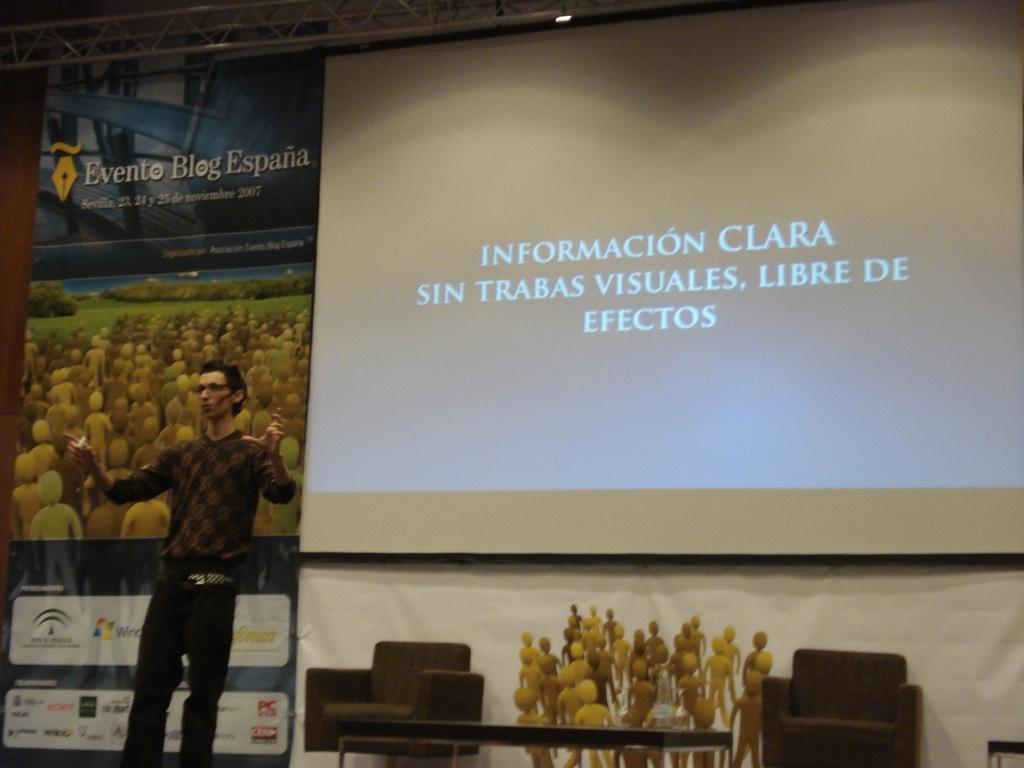What is the main subject of the image? There is a man in the image. What is the man doing in the image? The man is standing and talking. What can be seen behind the man? There is a screen and a banner behind the man. Can you describe the setting of the image? The setting might be on a stage, as indicated by the presence of a screen and cushioned chairs on either side. What type of stitch is being used to hold the badge on the man's shirt in the image? There is no badge visible on the man's shirt in the image, so it is not possible to determine the type of stitch being used. How does the heat affect the man's performance in the image? There is no indication of heat or temperature in the image, so it is not possible to determine its effect on the man's performance. 